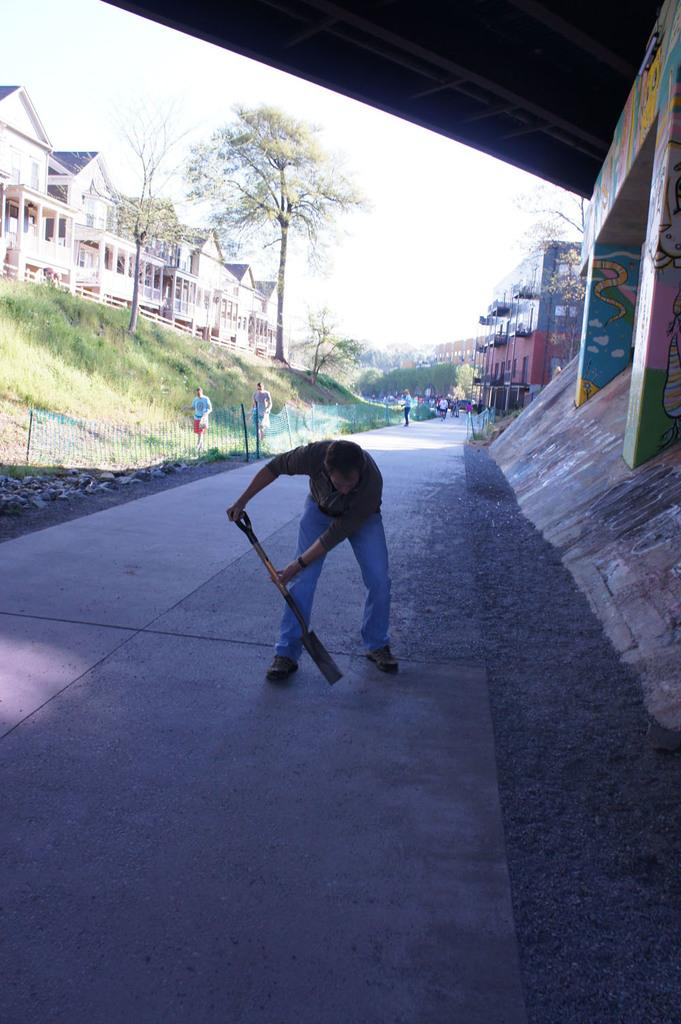Who is present in the image? There is a man in the image. What is the man holding in the image? The man is holding a tool. What can be seen on the left side of the image? There are trees and buildings on the left side of the image. What type of disease can be seen on the man's face in the image? There is no disease visible on the man's face in the image. What is the man using to brush his teeth in the image? There is no toothbrush present in the image, and the man is holding a tool, not a toothbrush. 